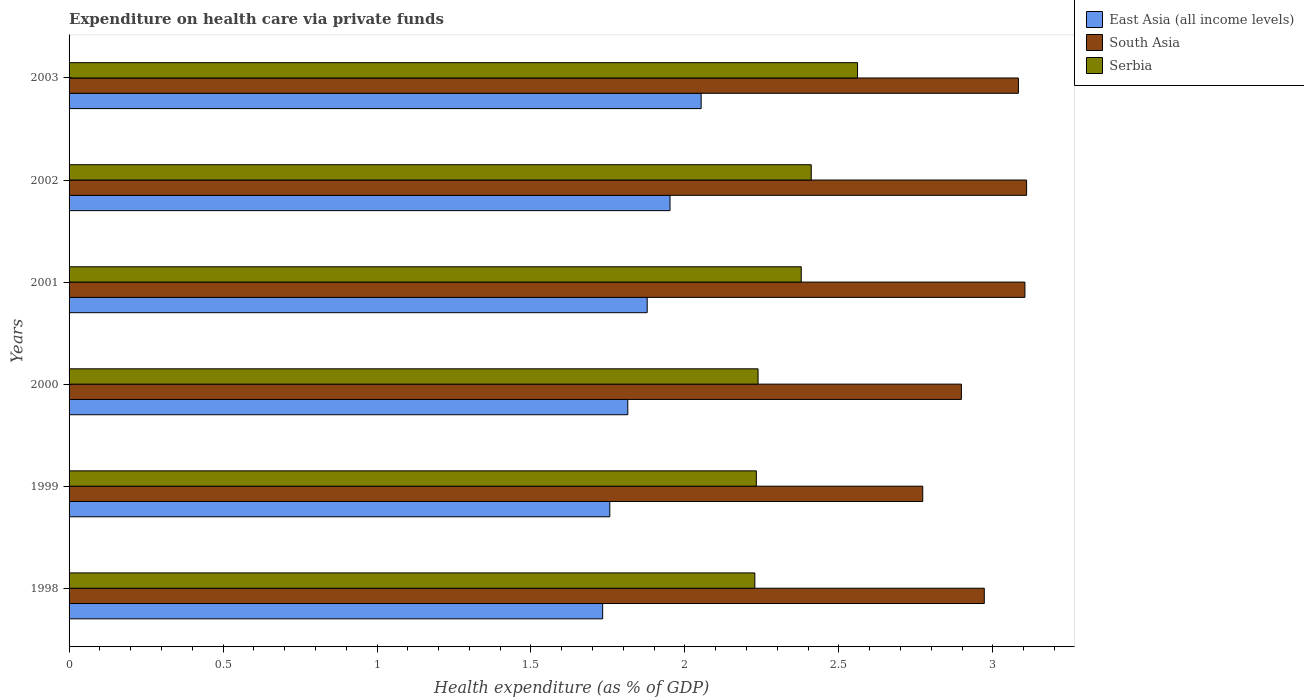How many different coloured bars are there?
Provide a short and direct response. 3. Are the number of bars per tick equal to the number of legend labels?
Offer a terse response. Yes. How many bars are there on the 6th tick from the top?
Offer a very short reply. 3. How many bars are there on the 2nd tick from the bottom?
Keep it short and to the point. 3. What is the expenditure made on health care in Serbia in 2001?
Offer a very short reply. 2.38. Across all years, what is the maximum expenditure made on health care in Serbia?
Give a very brief answer. 2.56. Across all years, what is the minimum expenditure made on health care in Serbia?
Your response must be concise. 2.23. What is the total expenditure made on health care in East Asia (all income levels) in the graph?
Offer a very short reply. 11.18. What is the difference between the expenditure made on health care in Serbia in 2000 and that in 2003?
Keep it short and to the point. -0.32. What is the difference between the expenditure made on health care in East Asia (all income levels) in 2001 and the expenditure made on health care in South Asia in 2003?
Your response must be concise. -1.21. What is the average expenditure made on health care in South Asia per year?
Offer a very short reply. 2.99. In the year 2003, what is the difference between the expenditure made on health care in Serbia and expenditure made on health care in South Asia?
Offer a terse response. -0.52. In how many years, is the expenditure made on health care in South Asia greater than 1 %?
Your answer should be compact. 6. What is the ratio of the expenditure made on health care in East Asia (all income levels) in 2001 to that in 2002?
Your answer should be compact. 0.96. Is the expenditure made on health care in East Asia (all income levels) in 1999 less than that in 2002?
Keep it short and to the point. Yes. What is the difference between the highest and the second highest expenditure made on health care in East Asia (all income levels)?
Give a very brief answer. 0.1. What is the difference between the highest and the lowest expenditure made on health care in South Asia?
Your answer should be very brief. 0.34. Is the sum of the expenditure made on health care in Serbia in 1998 and 1999 greater than the maximum expenditure made on health care in East Asia (all income levels) across all years?
Give a very brief answer. Yes. What does the 2nd bar from the top in 2001 represents?
Make the answer very short. South Asia. What does the 3rd bar from the bottom in 2002 represents?
Provide a short and direct response. Serbia. How many bars are there?
Offer a very short reply. 18. Are all the bars in the graph horizontal?
Your response must be concise. Yes. What is the difference between two consecutive major ticks on the X-axis?
Offer a very short reply. 0.5. Does the graph contain any zero values?
Keep it short and to the point. No. How many legend labels are there?
Provide a short and direct response. 3. What is the title of the graph?
Ensure brevity in your answer.  Expenditure on health care via private funds. What is the label or title of the X-axis?
Make the answer very short. Health expenditure (as % of GDP). What is the Health expenditure (as % of GDP) in East Asia (all income levels) in 1998?
Make the answer very short. 1.73. What is the Health expenditure (as % of GDP) of South Asia in 1998?
Your answer should be compact. 2.97. What is the Health expenditure (as % of GDP) in Serbia in 1998?
Your answer should be very brief. 2.23. What is the Health expenditure (as % of GDP) of East Asia (all income levels) in 1999?
Your answer should be compact. 1.76. What is the Health expenditure (as % of GDP) in South Asia in 1999?
Your answer should be very brief. 2.77. What is the Health expenditure (as % of GDP) in Serbia in 1999?
Provide a succinct answer. 2.23. What is the Health expenditure (as % of GDP) in East Asia (all income levels) in 2000?
Offer a terse response. 1.81. What is the Health expenditure (as % of GDP) of South Asia in 2000?
Offer a very short reply. 2.9. What is the Health expenditure (as % of GDP) in Serbia in 2000?
Your answer should be very brief. 2.24. What is the Health expenditure (as % of GDP) in East Asia (all income levels) in 2001?
Keep it short and to the point. 1.88. What is the Health expenditure (as % of GDP) in South Asia in 2001?
Your answer should be very brief. 3.1. What is the Health expenditure (as % of GDP) in Serbia in 2001?
Give a very brief answer. 2.38. What is the Health expenditure (as % of GDP) of East Asia (all income levels) in 2002?
Your answer should be compact. 1.95. What is the Health expenditure (as % of GDP) of South Asia in 2002?
Your response must be concise. 3.11. What is the Health expenditure (as % of GDP) in Serbia in 2002?
Your answer should be compact. 2.41. What is the Health expenditure (as % of GDP) in East Asia (all income levels) in 2003?
Keep it short and to the point. 2.05. What is the Health expenditure (as % of GDP) of South Asia in 2003?
Make the answer very short. 3.08. What is the Health expenditure (as % of GDP) of Serbia in 2003?
Your answer should be compact. 2.56. Across all years, what is the maximum Health expenditure (as % of GDP) in East Asia (all income levels)?
Offer a terse response. 2.05. Across all years, what is the maximum Health expenditure (as % of GDP) in South Asia?
Offer a terse response. 3.11. Across all years, what is the maximum Health expenditure (as % of GDP) in Serbia?
Your response must be concise. 2.56. Across all years, what is the minimum Health expenditure (as % of GDP) of East Asia (all income levels)?
Ensure brevity in your answer.  1.73. Across all years, what is the minimum Health expenditure (as % of GDP) of South Asia?
Provide a short and direct response. 2.77. Across all years, what is the minimum Health expenditure (as % of GDP) in Serbia?
Provide a succinct answer. 2.23. What is the total Health expenditure (as % of GDP) of East Asia (all income levels) in the graph?
Offer a terse response. 11.18. What is the total Health expenditure (as % of GDP) of South Asia in the graph?
Offer a terse response. 17.94. What is the total Health expenditure (as % of GDP) of Serbia in the graph?
Provide a short and direct response. 14.04. What is the difference between the Health expenditure (as % of GDP) in East Asia (all income levels) in 1998 and that in 1999?
Ensure brevity in your answer.  -0.02. What is the difference between the Health expenditure (as % of GDP) of South Asia in 1998 and that in 1999?
Your answer should be very brief. 0.2. What is the difference between the Health expenditure (as % of GDP) of Serbia in 1998 and that in 1999?
Your answer should be very brief. -0. What is the difference between the Health expenditure (as % of GDP) of East Asia (all income levels) in 1998 and that in 2000?
Ensure brevity in your answer.  -0.08. What is the difference between the Health expenditure (as % of GDP) of South Asia in 1998 and that in 2000?
Your answer should be compact. 0.07. What is the difference between the Health expenditure (as % of GDP) in Serbia in 1998 and that in 2000?
Your answer should be very brief. -0.01. What is the difference between the Health expenditure (as % of GDP) of East Asia (all income levels) in 1998 and that in 2001?
Your response must be concise. -0.14. What is the difference between the Health expenditure (as % of GDP) in South Asia in 1998 and that in 2001?
Make the answer very short. -0.13. What is the difference between the Health expenditure (as % of GDP) of Serbia in 1998 and that in 2001?
Your response must be concise. -0.15. What is the difference between the Health expenditure (as % of GDP) of East Asia (all income levels) in 1998 and that in 2002?
Offer a terse response. -0.22. What is the difference between the Health expenditure (as % of GDP) in South Asia in 1998 and that in 2002?
Offer a very short reply. -0.14. What is the difference between the Health expenditure (as % of GDP) of Serbia in 1998 and that in 2002?
Your answer should be very brief. -0.18. What is the difference between the Health expenditure (as % of GDP) of East Asia (all income levels) in 1998 and that in 2003?
Your answer should be very brief. -0.32. What is the difference between the Health expenditure (as % of GDP) in South Asia in 1998 and that in 2003?
Offer a very short reply. -0.11. What is the difference between the Health expenditure (as % of GDP) in Serbia in 1998 and that in 2003?
Offer a very short reply. -0.33. What is the difference between the Health expenditure (as % of GDP) in East Asia (all income levels) in 1999 and that in 2000?
Make the answer very short. -0.06. What is the difference between the Health expenditure (as % of GDP) of South Asia in 1999 and that in 2000?
Keep it short and to the point. -0.13. What is the difference between the Health expenditure (as % of GDP) of Serbia in 1999 and that in 2000?
Your answer should be very brief. -0.01. What is the difference between the Health expenditure (as % of GDP) of East Asia (all income levels) in 1999 and that in 2001?
Your answer should be very brief. -0.12. What is the difference between the Health expenditure (as % of GDP) of South Asia in 1999 and that in 2001?
Make the answer very short. -0.33. What is the difference between the Health expenditure (as % of GDP) in Serbia in 1999 and that in 2001?
Offer a very short reply. -0.15. What is the difference between the Health expenditure (as % of GDP) of East Asia (all income levels) in 1999 and that in 2002?
Your answer should be very brief. -0.2. What is the difference between the Health expenditure (as % of GDP) of South Asia in 1999 and that in 2002?
Provide a succinct answer. -0.34. What is the difference between the Health expenditure (as % of GDP) in Serbia in 1999 and that in 2002?
Make the answer very short. -0.18. What is the difference between the Health expenditure (as % of GDP) in East Asia (all income levels) in 1999 and that in 2003?
Keep it short and to the point. -0.3. What is the difference between the Health expenditure (as % of GDP) of South Asia in 1999 and that in 2003?
Offer a terse response. -0.31. What is the difference between the Health expenditure (as % of GDP) in Serbia in 1999 and that in 2003?
Offer a terse response. -0.33. What is the difference between the Health expenditure (as % of GDP) of East Asia (all income levels) in 2000 and that in 2001?
Keep it short and to the point. -0.06. What is the difference between the Health expenditure (as % of GDP) in South Asia in 2000 and that in 2001?
Offer a terse response. -0.21. What is the difference between the Health expenditure (as % of GDP) in Serbia in 2000 and that in 2001?
Ensure brevity in your answer.  -0.14. What is the difference between the Health expenditure (as % of GDP) in East Asia (all income levels) in 2000 and that in 2002?
Provide a succinct answer. -0.14. What is the difference between the Health expenditure (as % of GDP) in South Asia in 2000 and that in 2002?
Provide a succinct answer. -0.21. What is the difference between the Health expenditure (as % of GDP) of Serbia in 2000 and that in 2002?
Provide a short and direct response. -0.17. What is the difference between the Health expenditure (as % of GDP) in East Asia (all income levels) in 2000 and that in 2003?
Keep it short and to the point. -0.24. What is the difference between the Health expenditure (as % of GDP) of South Asia in 2000 and that in 2003?
Offer a very short reply. -0.19. What is the difference between the Health expenditure (as % of GDP) of Serbia in 2000 and that in 2003?
Your answer should be very brief. -0.32. What is the difference between the Health expenditure (as % of GDP) of East Asia (all income levels) in 2001 and that in 2002?
Your answer should be very brief. -0.07. What is the difference between the Health expenditure (as % of GDP) in South Asia in 2001 and that in 2002?
Your answer should be very brief. -0.01. What is the difference between the Health expenditure (as % of GDP) of Serbia in 2001 and that in 2002?
Offer a very short reply. -0.03. What is the difference between the Health expenditure (as % of GDP) in East Asia (all income levels) in 2001 and that in 2003?
Your answer should be compact. -0.18. What is the difference between the Health expenditure (as % of GDP) in South Asia in 2001 and that in 2003?
Your response must be concise. 0.02. What is the difference between the Health expenditure (as % of GDP) in Serbia in 2001 and that in 2003?
Ensure brevity in your answer.  -0.18. What is the difference between the Health expenditure (as % of GDP) of East Asia (all income levels) in 2002 and that in 2003?
Your answer should be compact. -0.1. What is the difference between the Health expenditure (as % of GDP) in South Asia in 2002 and that in 2003?
Your response must be concise. 0.03. What is the difference between the Health expenditure (as % of GDP) in Serbia in 2002 and that in 2003?
Offer a very short reply. -0.15. What is the difference between the Health expenditure (as % of GDP) of East Asia (all income levels) in 1998 and the Health expenditure (as % of GDP) of South Asia in 1999?
Provide a succinct answer. -1.04. What is the difference between the Health expenditure (as % of GDP) of East Asia (all income levels) in 1998 and the Health expenditure (as % of GDP) of Serbia in 1999?
Provide a succinct answer. -0.5. What is the difference between the Health expenditure (as % of GDP) in South Asia in 1998 and the Health expenditure (as % of GDP) in Serbia in 1999?
Offer a very short reply. 0.74. What is the difference between the Health expenditure (as % of GDP) in East Asia (all income levels) in 1998 and the Health expenditure (as % of GDP) in South Asia in 2000?
Your answer should be very brief. -1.17. What is the difference between the Health expenditure (as % of GDP) in East Asia (all income levels) in 1998 and the Health expenditure (as % of GDP) in Serbia in 2000?
Offer a terse response. -0.5. What is the difference between the Health expenditure (as % of GDP) of South Asia in 1998 and the Health expenditure (as % of GDP) of Serbia in 2000?
Your response must be concise. 0.73. What is the difference between the Health expenditure (as % of GDP) of East Asia (all income levels) in 1998 and the Health expenditure (as % of GDP) of South Asia in 2001?
Offer a very short reply. -1.37. What is the difference between the Health expenditure (as % of GDP) of East Asia (all income levels) in 1998 and the Health expenditure (as % of GDP) of Serbia in 2001?
Your response must be concise. -0.64. What is the difference between the Health expenditure (as % of GDP) of South Asia in 1998 and the Health expenditure (as % of GDP) of Serbia in 2001?
Give a very brief answer. 0.59. What is the difference between the Health expenditure (as % of GDP) in East Asia (all income levels) in 1998 and the Health expenditure (as % of GDP) in South Asia in 2002?
Make the answer very short. -1.38. What is the difference between the Health expenditure (as % of GDP) of East Asia (all income levels) in 1998 and the Health expenditure (as % of GDP) of Serbia in 2002?
Your response must be concise. -0.68. What is the difference between the Health expenditure (as % of GDP) in South Asia in 1998 and the Health expenditure (as % of GDP) in Serbia in 2002?
Offer a terse response. 0.56. What is the difference between the Health expenditure (as % of GDP) of East Asia (all income levels) in 1998 and the Health expenditure (as % of GDP) of South Asia in 2003?
Make the answer very short. -1.35. What is the difference between the Health expenditure (as % of GDP) in East Asia (all income levels) in 1998 and the Health expenditure (as % of GDP) in Serbia in 2003?
Give a very brief answer. -0.83. What is the difference between the Health expenditure (as % of GDP) of South Asia in 1998 and the Health expenditure (as % of GDP) of Serbia in 2003?
Your response must be concise. 0.41. What is the difference between the Health expenditure (as % of GDP) of East Asia (all income levels) in 1999 and the Health expenditure (as % of GDP) of South Asia in 2000?
Your response must be concise. -1.14. What is the difference between the Health expenditure (as % of GDP) in East Asia (all income levels) in 1999 and the Health expenditure (as % of GDP) in Serbia in 2000?
Your answer should be very brief. -0.48. What is the difference between the Health expenditure (as % of GDP) in South Asia in 1999 and the Health expenditure (as % of GDP) in Serbia in 2000?
Offer a very short reply. 0.53. What is the difference between the Health expenditure (as % of GDP) in East Asia (all income levels) in 1999 and the Health expenditure (as % of GDP) in South Asia in 2001?
Provide a succinct answer. -1.35. What is the difference between the Health expenditure (as % of GDP) in East Asia (all income levels) in 1999 and the Health expenditure (as % of GDP) in Serbia in 2001?
Provide a short and direct response. -0.62. What is the difference between the Health expenditure (as % of GDP) of South Asia in 1999 and the Health expenditure (as % of GDP) of Serbia in 2001?
Provide a succinct answer. 0.39. What is the difference between the Health expenditure (as % of GDP) in East Asia (all income levels) in 1999 and the Health expenditure (as % of GDP) in South Asia in 2002?
Provide a succinct answer. -1.35. What is the difference between the Health expenditure (as % of GDP) of East Asia (all income levels) in 1999 and the Health expenditure (as % of GDP) of Serbia in 2002?
Provide a short and direct response. -0.65. What is the difference between the Health expenditure (as % of GDP) in South Asia in 1999 and the Health expenditure (as % of GDP) in Serbia in 2002?
Give a very brief answer. 0.36. What is the difference between the Health expenditure (as % of GDP) in East Asia (all income levels) in 1999 and the Health expenditure (as % of GDP) in South Asia in 2003?
Your response must be concise. -1.33. What is the difference between the Health expenditure (as % of GDP) in East Asia (all income levels) in 1999 and the Health expenditure (as % of GDP) in Serbia in 2003?
Provide a short and direct response. -0.8. What is the difference between the Health expenditure (as % of GDP) of South Asia in 1999 and the Health expenditure (as % of GDP) of Serbia in 2003?
Ensure brevity in your answer.  0.21. What is the difference between the Health expenditure (as % of GDP) in East Asia (all income levels) in 2000 and the Health expenditure (as % of GDP) in South Asia in 2001?
Provide a short and direct response. -1.29. What is the difference between the Health expenditure (as % of GDP) of East Asia (all income levels) in 2000 and the Health expenditure (as % of GDP) of Serbia in 2001?
Offer a very short reply. -0.56. What is the difference between the Health expenditure (as % of GDP) in South Asia in 2000 and the Health expenditure (as % of GDP) in Serbia in 2001?
Provide a short and direct response. 0.52. What is the difference between the Health expenditure (as % of GDP) in East Asia (all income levels) in 2000 and the Health expenditure (as % of GDP) in South Asia in 2002?
Your answer should be very brief. -1.29. What is the difference between the Health expenditure (as % of GDP) of East Asia (all income levels) in 2000 and the Health expenditure (as % of GDP) of Serbia in 2002?
Provide a succinct answer. -0.6. What is the difference between the Health expenditure (as % of GDP) of South Asia in 2000 and the Health expenditure (as % of GDP) of Serbia in 2002?
Your answer should be compact. 0.49. What is the difference between the Health expenditure (as % of GDP) in East Asia (all income levels) in 2000 and the Health expenditure (as % of GDP) in South Asia in 2003?
Make the answer very short. -1.27. What is the difference between the Health expenditure (as % of GDP) in East Asia (all income levels) in 2000 and the Health expenditure (as % of GDP) in Serbia in 2003?
Provide a succinct answer. -0.75. What is the difference between the Health expenditure (as % of GDP) of South Asia in 2000 and the Health expenditure (as % of GDP) of Serbia in 2003?
Your answer should be very brief. 0.34. What is the difference between the Health expenditure (as % of GDP) in East Asia (all income levels) in 2001 and the Health expenditure (as % of GDP) in South Asia in 2002?
Keep it short and to the point. -1.23. What is the difference between the Health expenditure (as % of GDP) in East Asia (all income levels) in 2001 and the Health expenditure (as % of GDP) in Serbia in 2002?
Give a very brief answer. -0.53. What is the difference between the Health expenditure (as % of GDP) in South Asia in 2001 and the Health expenditure (as % of GDP) in Serbia in 2002?
Make the answer very short. 0.69. What is the difference between the Health expenditure (as % of GDP) in East Asia (all income levels) in 2001 and the Health expenditure (as % of GDP) in South Asia in 2003?
Offer a very short reply. -1.21. What is the difference between the Health expenditure (as % of GDP) in East Asia (all income levels) in 2001 and the Health expenditure (as % of GDP) in Serbia in 2003?
Offer a very short reply. -0.68. What is the difference between the Health expenditure (as % of GDP) of South Asia in 2001 and the Health expenditure (as % of GDP) of Serbia in 2003?
Your answer should be compact. 0.54. What is the difference between the Health expenditure (as % of GDP) of East Asia (all income levels) in 2002 and the Health expenditure (as % of GDP) of South Asia in 2003?
Provide a succinct answer. -1.13. What is the difference between the Health expenditure (as % of GDP) of East Asia (all income levels) in 2002 and the Health expenditure (as % of GDP) of Serbia in 2003?
Provide a succinct answer. -0.61. What is the difference between the Health expenditure (as % of GDP) in South Asia in 2002 and the Health expenditure (as % of GDP) in Serbia in 2003?
Offer a very short reply. 0.55. What is the average Health expenditure (as % of GDP) of East Asia (all income levels) per year?
Your answer should be compact. 1.86. What is the average Health expenditure (as % of GDP) of South Asia per year?
Ensure brevity in your answer.  2.99. What is the average Health expenditure (as % of GDP) of Serbia per year?
Your response must be concise. 2.34. In the year 1998, what is the difference between the Health expenditure (as % of GDP) in East Asia (all income levels) and Health expenditure (as % of GDP) in South Asia?
Provide a succinct answer. -1.24. In the year 1998, what is the difference between the Health expenditure (as % of GDP) of East Asia (all income levels) and Health expenditure (as % of GDP) of Serbia?
Provide a short and direct response. -0.49. In the year 1998, what is the difference between the Health expenditure (as % of GDP) in South Asia and Health expenditure (as % of GDP) in Serbia?
Keep it short and to the point. 0.74. In the year 1999, what is the difference between the Health expenditure (as % of GDP) in East Asia (all income levels) and Health expenditure (as % of GDP) in South Asia?
Offer a terse response. -1.02. In the year 1999, what is the difference between the Health expenditure (as % of GDP) of East Asia (all income levels) and Health expenditure (as % of GDP) of Serbia?
Your answer should be compact. -0.48. In the year 1999, what is the difference between the Health expenditure (as % of GDP) in South Asia and Health expenditure (as % of GDP) in Serbia?
Your answer should be compact. 0.54. In the year 2000, what is the difference between the Health expenditure (as % of GDP) of East Asia (all income levels) and Health expenditure (as % of GDP) of South Asia?
Your response must be concise. -1.08. In the year 2000, what is the difference between the Health expenditure (as % of GDP) in East Asia (all income levels) and Health expenditure (as % of GDP) in Serbia?
Provide a short and direct response. -0.42. In the year 2000, what is the difference between the Health expenditure (as % of GDP) in South Asia and Health expenditure (as % of GDP) in Serbia?
Offer a very short reply. 0.66. In the year 2001, what is the difference between the Health expenditure (as % of GDP) in East Asia (all income levels) and Health expenditure (as % of GDP) in South Asia?
Make the answer very short. -1.23. In the year 2001, what is the difference between the Health expenditure (as % of GDP) of East Asia (all income levels) and Health expenditure (as % of GDP) of Serbia?
Provide a succinct answer. -0.5. In the year 2001, what is the difference between the Health expenditure (as % of GDP) of South Asia and Health expenditure (as % of GDP) of Serbia?
Offer a very short reply. 0.73. In the year 2002, what is the difference between the Health expenditure (as % of GDP) in East Asia (all income levels) and Health expenditure (as % of GDP) in South Asia?
Your response must be concise. -1.16. In the year 2002, what is the difference between the Health expenditure (as % of GDP) in East Asia (all income levels) and Health expenditure (as % of GDP) in Serbia?
Provide a succinct answer. -0.46. In the year 2002, what is the difference between the Health expenditure (as % of GDP) of South Asia and Health expenditure (as % of GDP) of Serbia?
Ensure brevity in your answer.  0.7. In the year 2003, what is the difference between the Health expenditure (as % of GDP) in East Asia (all income levels) and Health expenditure (as % of GDP) in South Asia?
Ensure brevity in your answer.  -1.03. In the year 2003, what is the difference between the Health expenditure (as % of GDP) in East Asia (all income levels) and Health expenditure (as % of GDP) in Serbia?
Ensure brevity in your answer.  -0.51. In the year 2003, what is the difference between the Health expenditure (as % of GDP) in South Asia and Health expenditure (as % of GDP) in Serbia?
Offer a terse response. 0.52. What is the ratio of the Health expenditure (as % of GDP) in South Asia in 1998 to that in 1999?
Give a very brief answer. 1.07. What is the ratio of the Health expenditure (as % of GDP) in Serbia in 1998 to that in 1999?
Give a very brief answer. 1. What is the ratio of the Health expenditure (as % of GDP) in East Asia (all income levels) in 1998 to that in 2000?
Make the answer very short. 0.95. What is the ratio of the Health expenditure (as % of GDP) in South Asia in 1998 to that in 2000?
Your answer should be compact. 1.03. What is the ratio of the Health expenditure (as % of GDP) in Serbia in 1998 to that in 2000?
Give a very brief answer. 1. What is the ratio of the Health expenditure (as % of GDP) in East Asia (all income levels) in 1998 to that in 2001?
Ensure brevity in your answer.  0.92. What is the ratio of the Health expenditure (as % of GDP) of South Asia in 1998 to that in 2001?
Make the answer very short. 0.96. What is the ratio of the Health expenditure (as % of GDP) of Serbia in 1998 to that in 2001?
Your answer should be compact. 0.94. What is the ratio of the Health expenditure (as % of GDP) in East Asia (all income levels) in 1998 to that in 2002?
Offer a very short reply. 0.89. What is the ratio of the Health expenditure (as % of GDP) in South Asia in 1998 to that in 2002?
Give a very brief answer. 0.96. What is the ratio of the Health expenditure (as % of GDP) of Serbia in 1998 to that in 2002?
Provide a short and direct response. 0.92. What is the ratio of the Health expenditure (as % of GDP) in East Asia (all income levels) in 1998 to that in 2003?
Offer a terse response. 0.84. What is the ratio of the Health expenditure (as % of GDP) in South Asia in 1998 to that in 2003?
Your response must be concise. 0.96. What is the ratio of the Health expenditure (as % of GDP) of Serbia in 1998 to that in 2003?
Your answer should be compact. 0.87. What is the ratio of the Health expenditure (as % of GDP) of East Asia (all income levels) in 1999 to that in 2000?
Offer a terse response. 0.97. What is the ratio of the Health expenditure (as % of GDP) of South Asia in 1999 to that in 2000?
Keep it short and to the point. 0.96. What is the ratio of the Health expenditure (as % of GDP) in East Asia (all income levels) in 1999 to that in 2001?
Offer a very short reply. 0.94. What is the ratio of the Health expenditure (as % of GDP) of South Asia in 1999 to that in 2001?
Provide a succinct answer. 0.89. What is the ratio of the Health expenditure (as % of GDP) in Serbia in 1999 to that in 2001?
Your answer should be very brief. 0.94. What is the ratio of the Health expenditure (as % of GDP) of East Asia (all income levels) in 1999 to that in 2002?
Offer a terse response. 0.9. What is the ratio of the Health expenditure (as % of GDP) of South Asia in 1999 to that in 2002?
Your response must be concise. 0.89. What is the ratio of the Health expenditure (as % of GDP) in Serbia in 1999 to that in 2002?
Offer a very short reply. 0.93. What is the ratio of the Health expenditure (as % of GDP) in East Asia (all income levels) in 1999 to that in 2003?
Offer a terse response. 0.86. What is the ratio of the Health expenditure (as % of GDP) in South Asia in 1999 to that in 2003?
Ensure brevity in your answer.  0.9. What is the ratio of the Health expenditure (as % of GDP) of Serbia in 1999 to that in 2003?
Ensure brevity in your answer.  0.87. What is the ratio of the Health expenditure (as % of GDP) of East Asia (all income levels) in 2000 to that in 2001?
Your answer should be very brief. 0.97. What is the ratio of the Health expenditure (as % of GDP) of South Asia in 2000 to that in 2001?
Ensure brevity in your answer.  0.93. What is the ratio of the Health expenditure (as % of GDP) of Serbia in 2000 to that in 2001?
Ensure brevity in your answer.  0.94. What is the ratio of the Health expenditure (as % of GDP) in East Asia (all income levels) in 2000 to that in 2002?
Ensure brevity in your answer.  0.93. What is the ratio of the Health expenditure (as % of GDP) in South Asia in 2000 to that in 2002?
Ensure brevity in your answer.  0.93. What is the ratio of the Health expenditure (as % of GDP) in Serbia in 2000 to that in 2002?
Ensure brevity in your answer.  0.93. What is the ratio of the Health expenditure (as % of GDP) of East Asia (all income levels) in 2000 to that in 2003?
Keep it short and to the point. 0.88. What is the ratio of the Health expenditure (as % of GDP) in South Asia in 2000 to that in 2003?
Your answer should be compact. 0.94. What is the ratio of the Health expenditure (as % of GDP) of Serbia in 2000 to that in 2003?
Offer a very short reply. 0.87. What is the ratio of the Health expenditure (as % of GDP) of East Asia (all income levels) in 2001 to that in 2002?
Keep it short and to the point. 0.96. What is the ratio of the Health expenditure (as % of GDP) in South Asia in 2001 to that in 2002?
Provide a short and direct response. 1. What is the ratio of the Health expenditure (as % of GDP) of Serbia in 2001 to that in 2002?
Ensure brevity in your answer.  0.99. What is the ratio of the Health expenditure (as % of GDP) in East Asia (all income levels) in 2001 to that in 2003?
Ensure brevity in your answer.  0.91. What is the ratio of the Health expenditure (as % of GDP) in Serbia in 2001 to that in 2003?
Provide a succinct answer. 0.93. What is the ratio of the Health expenditure (as % of GDP) of East Asia (all income levels) in 2002 to that in 2003?
Your answer should be very brief. 0.95. What is the ratio of the Health expenditure (as % of GDP) of South Asia in 2002 to that in 2003?
Make the answer very short. 1.01. What is the ratio of the Health expenditure (as % of GDP) of Serbia in 2002 to that in 2003?
Give a very brief answer. 0.94. What is the difference between the highest and the second highest Health expenditure (as % of GDP) in East Asia (all income levels)?
Your answer should be very brief. 0.1. What is the difference between the highest and the second highest Health expenditure (as % of GDP) of South Asia?
Offer a very short reply. 0.01. What is the difference between the highest and the second highest Health expenditure (as % of GDP) in Serbia?
Your response must be concise. 0.15. What is the difference between the highest and the lowest Health expenditure (as % of GDP) in East Asia (all income levels)?
Your answer should be compact. 0.32. What is the difference between the highest and the lowest Health expenditure (as % of GDP) in South Asia?
Offer a terse response. 0.34. What is the difference between the highest and the lowest Health expenditure (as % of GDP) of Serbia?
Make the answer very short. 0.33. 